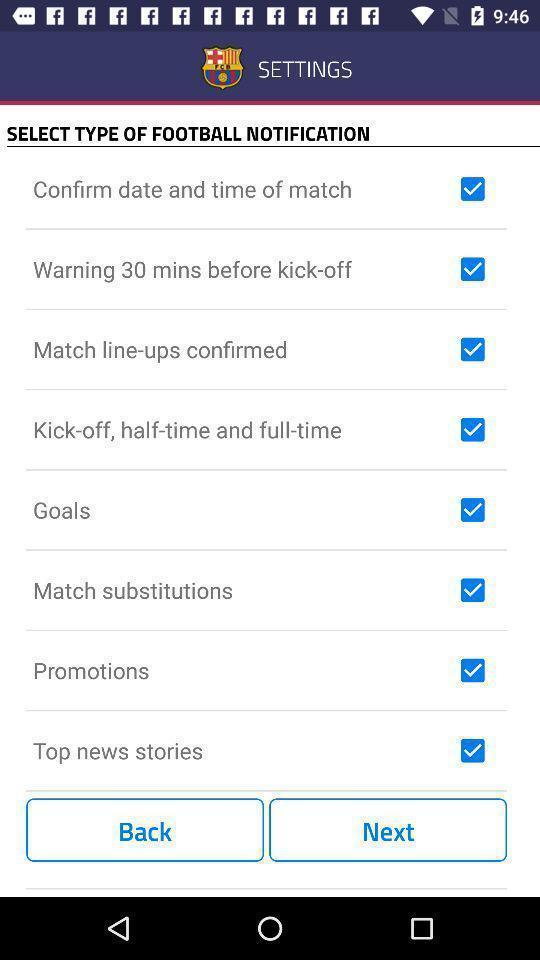Summarize the information in this screenshot. Page displaying various settings in app. 